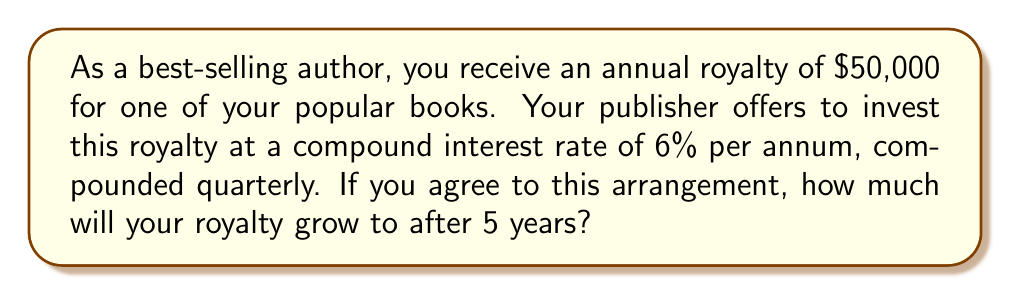Give your solution to this math problem. To solve this problem, we'll use the compound interest formula:

$$A = P(1 + \frac{r}{n})^{nt}$$

Where:
$A$ = Final amount
$P$ = Principal (initial investment)
$r$ = Annual interest rate (as a decimal)
$n$ = Number of times interest is compounded per year
$t$ = Number of years

Given:
$P = \$50,000$
$r = 0.06$ (6% expressed as a decimal)
$n = 4$ (compounded quarterly, so 4 times per year)
$t = 5$ years

Let's substitute these values into the formula:

$$A = 50,000(1 + \frac{0.06}{4})^{4 \cdot 5}$$

$$A = 50,000(1 + 0.015)^{20}$$

$$A = 50,000(1.015)^{20}$$

Using a calculator to evaluate $(1.015)^{20}$:

$$A = 50,000 \cdot 1.3468778$$

$$A = 67,343.89$$

Therefore, after 5 years, the royalty will grow to $67,343.89.
Answer: $67,343.89 